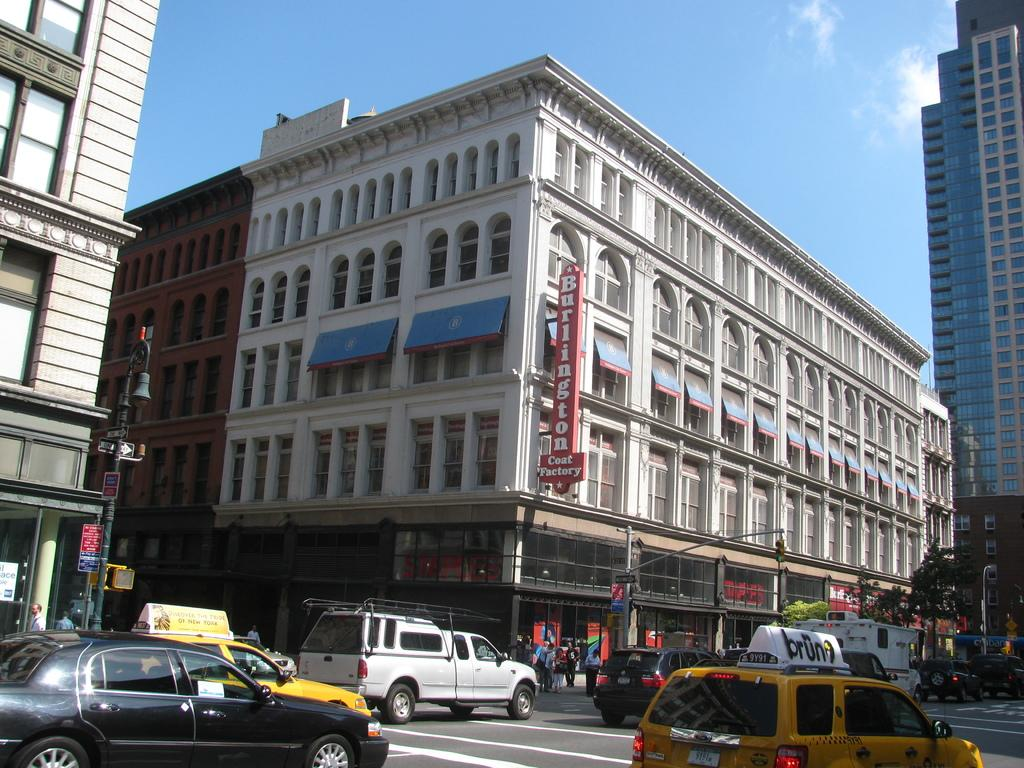Provide a one-sentence caption for the provided image. Cars drive past a Burlington Coat Factory under a blue sky. 